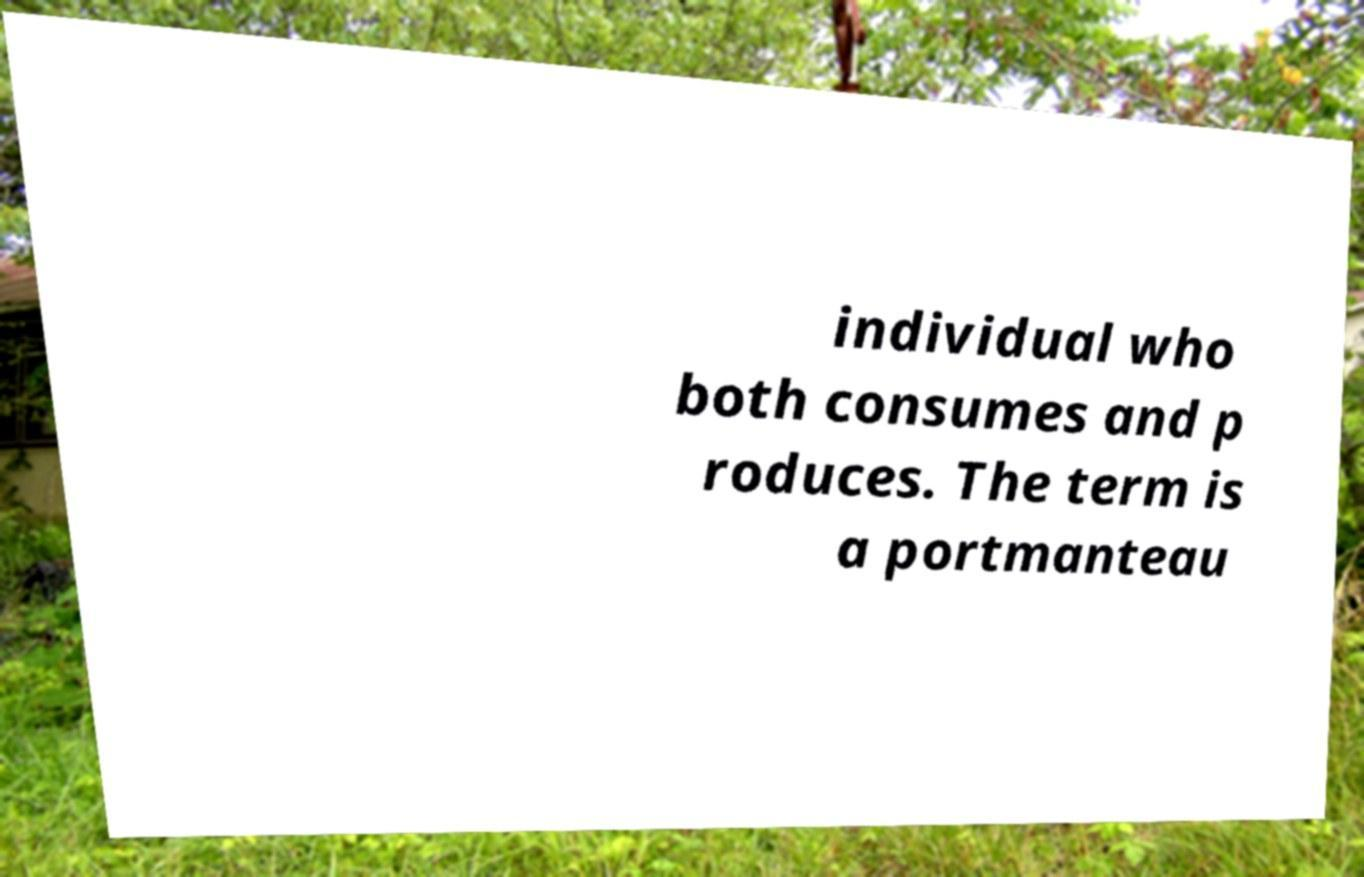Can you accurately transcribe the text from the provided image for me? individual who both consumes and p roduces. The term is a portmanteau 